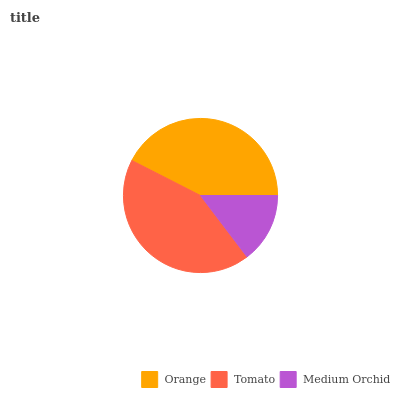Is Medium Orchid the minimum?
Answer yes or no. Yes. Is Tomato the maximum?
Answer yes or no. Yes. Is Tomato the minimum?
Answer yes or no. No. Is Medium Orchid the maximum?
Answer yes or no. No. Is Tomato greater than Medium Orchid?
Answer yes or no. Yes. Is Medium Orchid less than Tomato?
Answer yes or no. Yes. Is Medium Orchid greater than Tomato?
Answer yes or no. No. Is Tomato less than Medium Orchid?
Answer yes or no. No. Is Orange the high median?
Answer yes or no. Yes. Is Orange the low median?
Answer yes or no. Yes. Is Medium Orchid the high median?
Answer yes or no. No. Is Medium Orchid the low median?
Answer yes or no. No. 